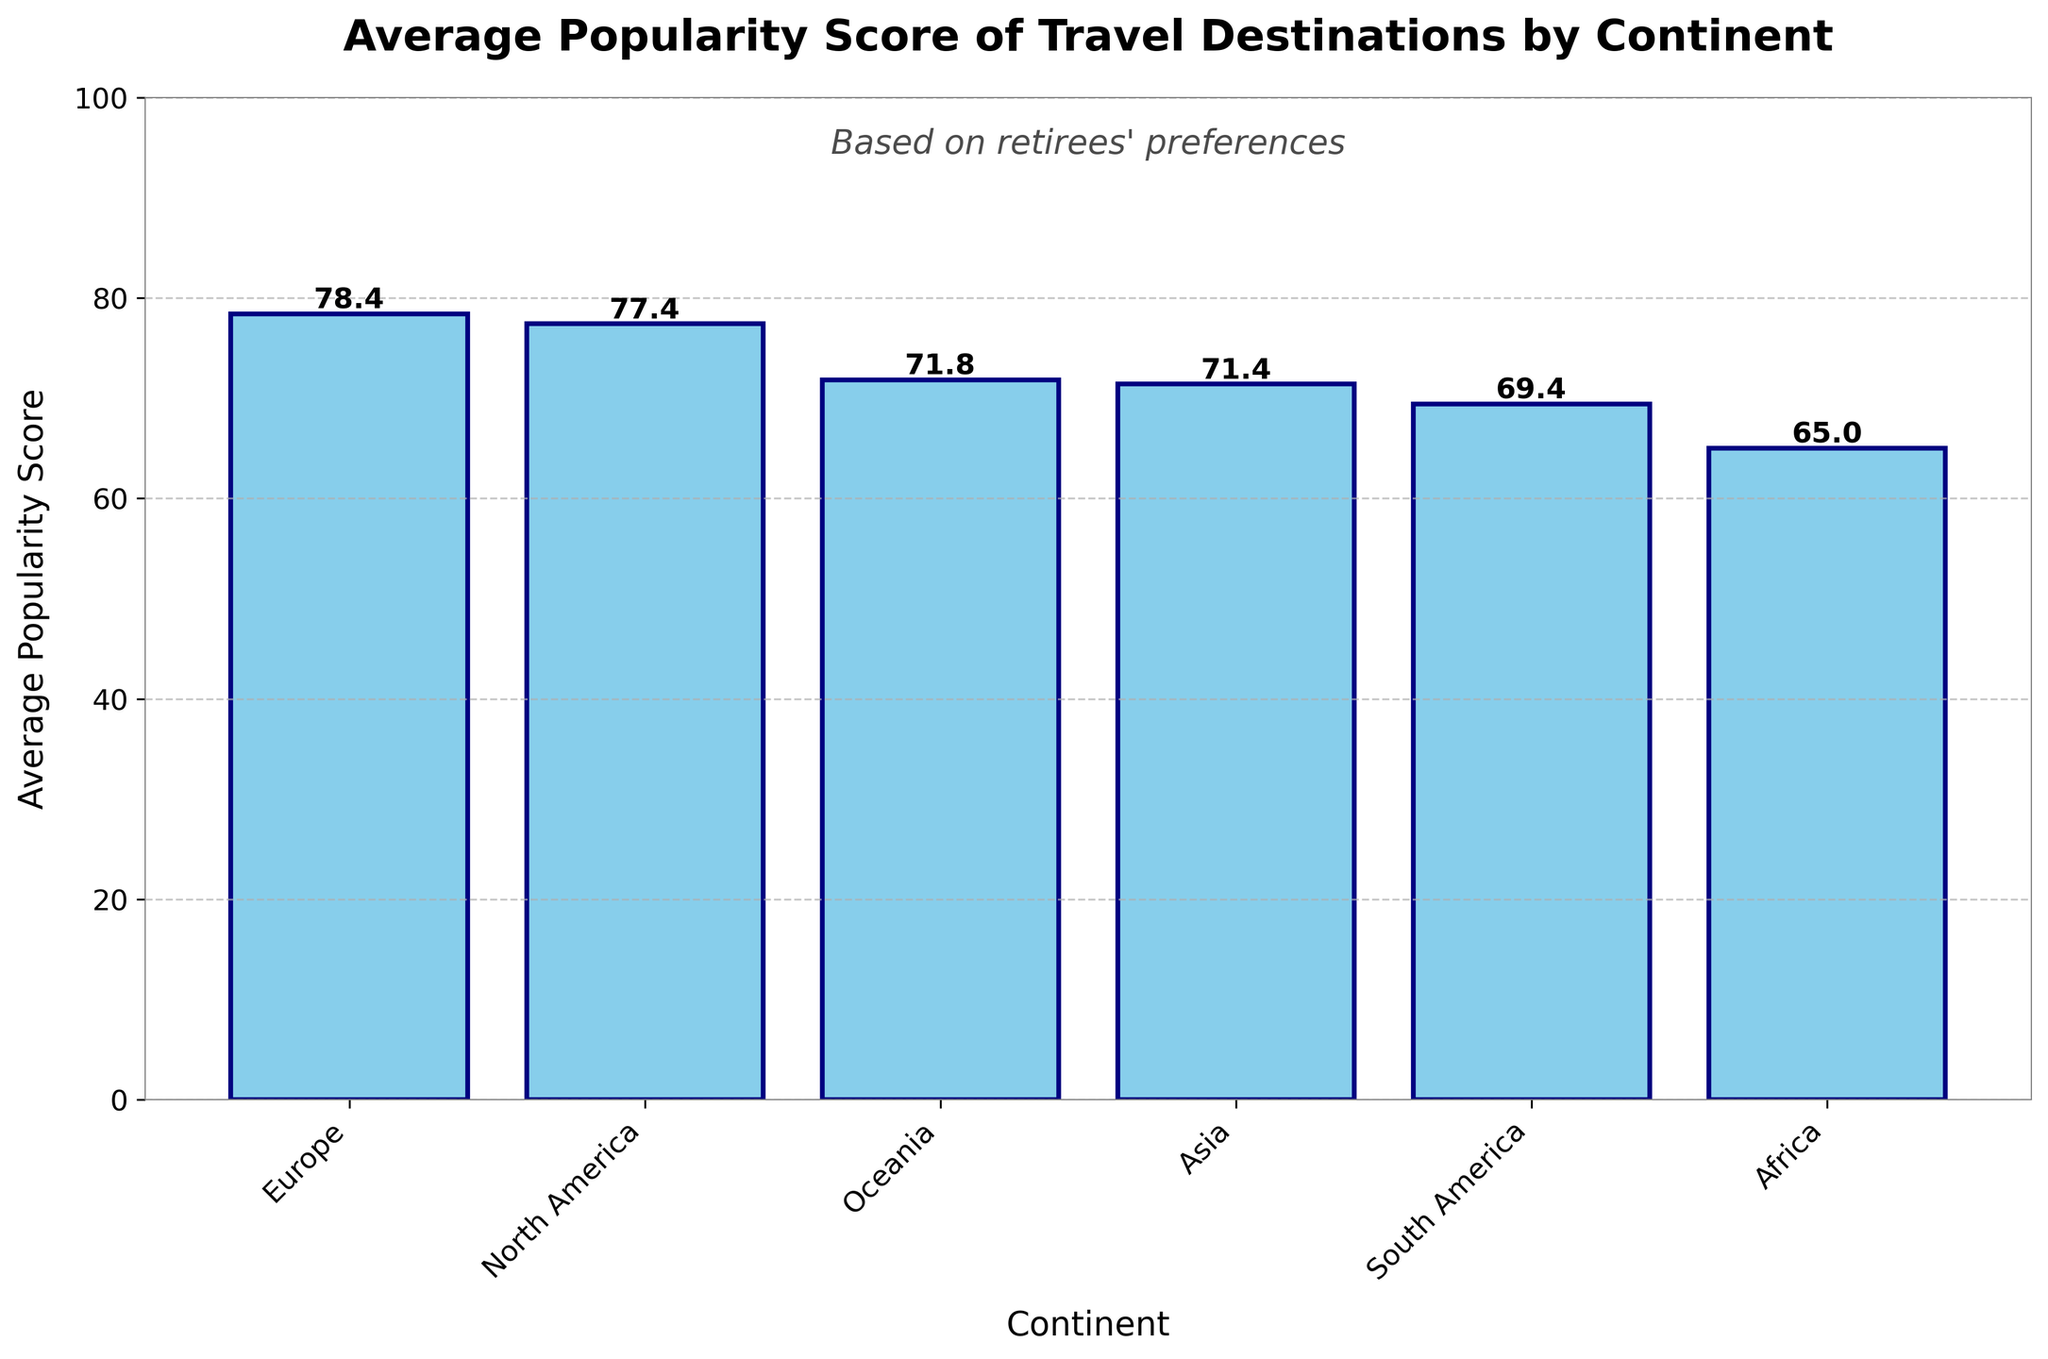What's the highest average popularity score by continent shown in the figure? By looking at the bar heights, we see that North America has the tallest bar, indicating the highest average popularity score.
Answer: North America What's the difference in average popularity score between Europe and Oceania? From the bar chart, find the heights of the bars for Europe and Oceania. Europe’s average score is about 78.4, and Oceania’s is approximately 71.8. Subtract Oceania’s average from Europe’s: 78.4 - 71.8.
Answer: 6.6 Which two continents have the closest average popularity scores? Inspect the bar heights to find the two bars that are most similar in height. Europe and South America have closely matching bars, with averages around 78.4 and 69.4 respectively.
Answer: Europe and South America What's the average popularity score of the continents with the two lowest values combined? Identify the continents with the lowest bars, which are Africa and Asia, with scores of 65.0 and 71.4 respectively. Calculate the average: (65.0 + 68.2) / 2.
Answer: 66.6 How many continents have an average popularity score above 70? Count the number of bars higher than the 70 mark on the y-axis. The continents are Europe, North America, Asia, and Oceania, making 4 in total.
Answer: 4 Which continent has a higher average popularity score: Africa or South America? Look at the heights of the bars for Africa and South America. South America has a bar taller than Africa, indicating a higher average.
Answer: South America By how much does the average popularity score of North America exceed that of Africa? From the bar chart, North America's average score is around 77.4, and Africa's is 65.0. Subtract Africa's score from North America's: 88 - 65.0.
Answer: 23.4 What is the average popularity score of all continents combined? Add the average scores of all the continents and divide by the number of continents (5). The average scores are 78.4 (Europe), 88 (North America), 71.4 (Asia), 69.4 (South America), 71.8 (Oceania), and 65.0 (Africa): (78.4 + 88 + 71.4 + 69.4 + 71.8 + 65.0) / 6
Answer: 74.33 